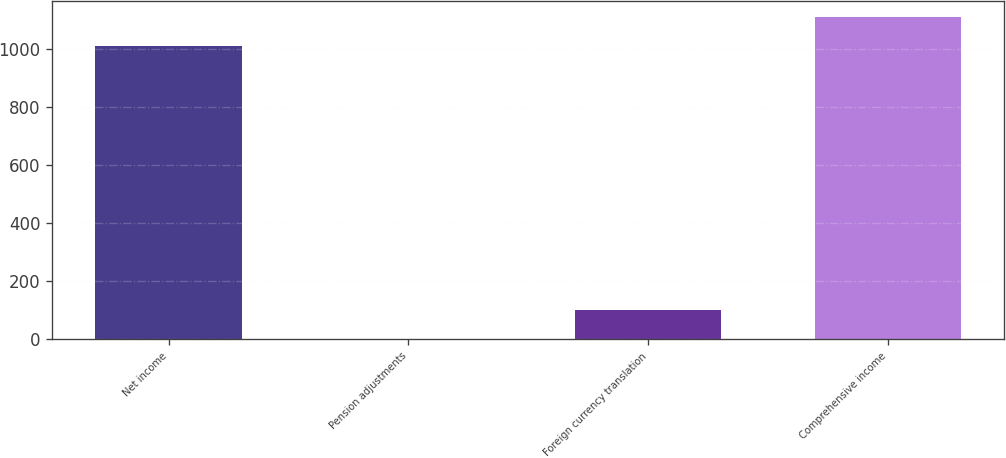Convert chart. <chart><loc_0><loc_0><loc_500><loc_500><bar_chart><fcel>Net income<fcel>Pension adjustments<fcel>Foreign currency translation<fcel>Comprehensive income<nl><fcel>1010.2<fcel>0.7<fcel>101.89<fcel>1111.39<nl></chart> 